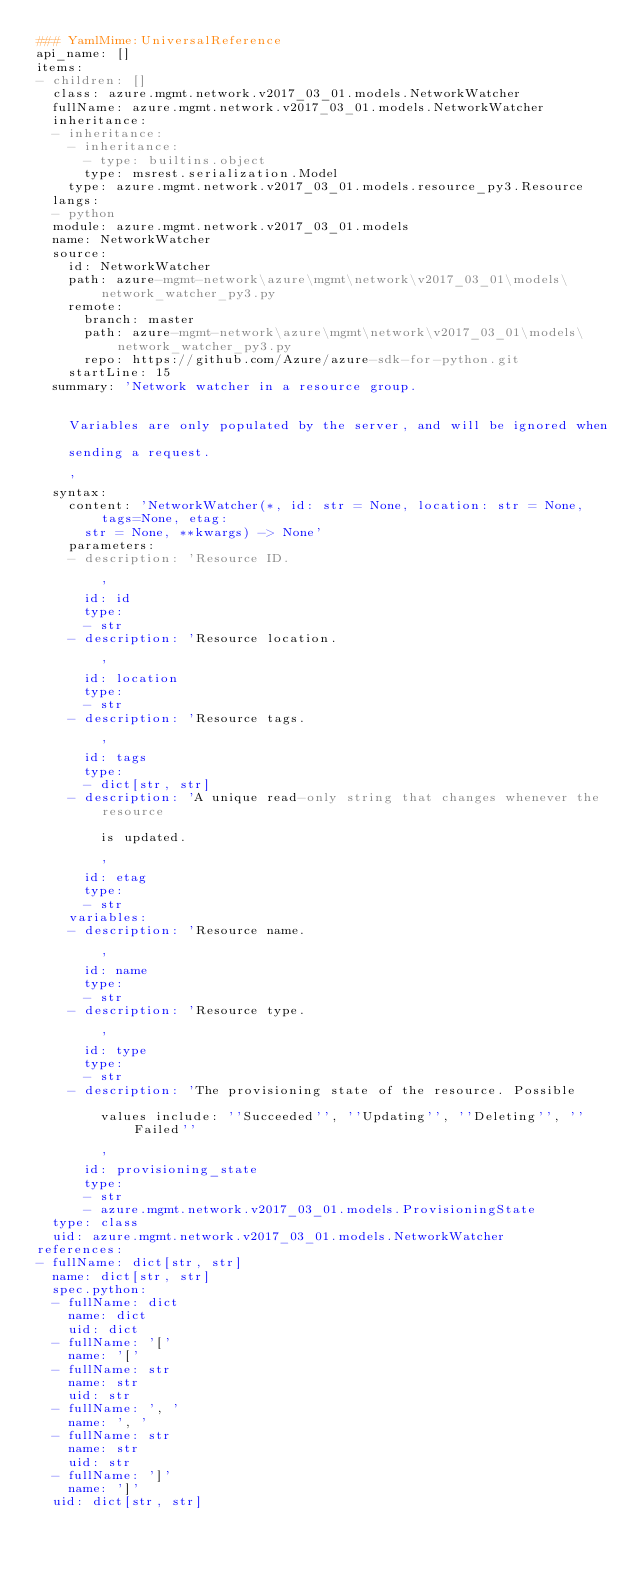<code> <loc_0><loc_0><loc_500><loc_500><_YAML_>### YamlMime:UniversalReference
api_name: []
items:
- children: []
  class: azure.mgmt.network.v2017_03_01.models.NetworkWatcher
  fullName: azure.mgmt.network.v2017_03_01.models.NetworkWatcher
  inheritance:
  - inheritance:
    - inheritance:
      - type: builtins.object
      type: msrest.serialization.Model
    type: azure.mgmt.network.v2017_03_01.models.resource_py3.Resource
  langs:
  - python
  module: azure.mgmt.network.v2017_03_01.models
  name: NetworkWatcher
  source:
    id: NetworkWatcher
    path: azure-mgmt-network\azure\mgmt\network\v2017_03_01\models\network_watcher_py3.py
    remote:
      branch: master
      path: azure-mgmt-network\azure\mgmt\network\v2017_03_01\models\network_watcher_py3.py
      repo: https://github.com/Azure/azure-sdk-for-python.git
    startLine: 15
  summary: 'Network watcher in a resource group.


    Variables are only populated by the server, and will be ignored when

    sending a request.

    '
  syntax:
    content: 'NetworkWatcher(*, id: str = None, location: str = None, tags=None, etag:
      str = None, **kwargs) -> None'
    parameters:
    - description: 'Resource ID.

        '
      id: id
      type:
      - str
    - description: 'Resource location.

        '
      id: location
      type:
      - str
    - description: 'Resource tags.

        '
      id: tags
      type:
      - dict[str, str]
    - description: 'A unique read-only string that changes whenever the resource

        is updated.

        '
      id: etag
      type:
      - str
    variables:
    - description: 'Resource name.

        '
      id: name
      type:
      - str
    - description: 'Resource type.

        '
      id: type
      type:
      - str
    - description: 'The provisioning state of the resource. Possible

        values include: ''Succeeded'', ''Updating'', ''Deleting'', ''Failed''

        '
      id: provisioning_state
      type:
      - str
      - azure.mgmt.network.v2017_03_01.models.ProvisioningState
  type: class
  uid: azure.mgmt.network.v2017_03_01.models.NetworkWatcher
references:
- fullName: dict[str, str]
  name: dict[str, str]
  spec.python:
  - fullName: dict
    name: dict
    uid: dict
  - fullName: '['
    name: '['
  - fullName: str
    name: str
    uid: str
  - fullName: ', '
    name: ', '
  - fullName: str
    name: str
    uid: str
  - fullName: ']'
    name: ']'
  uid: dict[str, str]
</code> 